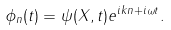<formula> <loc_0><loc_0><loc_500><loc_500>\phi _ { n } ( t ) = \psi ( X , t ) e ^ { i k n + i \omega t } .</formula> 